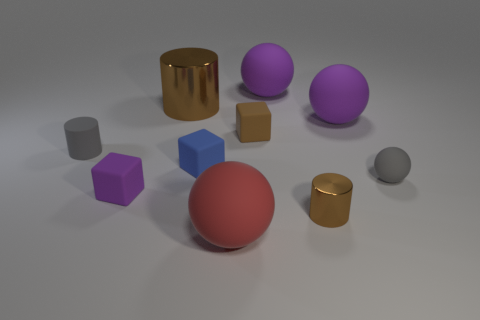There is a block that is the same color as the large metal thing; what material is it?
Keep it short and to the point. Rubber. How many other objects are the same color as the big cylinder?
Your answer should be compact. 2. Are there more small brown metal cylinders on the right side of the gray matte cylinder than large cyan cubes?
Offer a very short reply. Yes. What number of purple matte objects have the same size as the red matte thing?
Make the answer very short. 2. There is a metal object that is right of the red rubber thing; is it the same size as the ball that is in front of the small gray ball?
Your response must be concise. No. What size is the brown shiny object that is in front of the tiny gray cylinder?
Provide a succinct answer. Small. There is a gray rubber cylinder that is left of the shiny object in front of the large brown object; how big is it?
Your answer should be very brief. Small. There is a brown cylinder that is the same size as the blue thing; what material is it?
Your answer should be very brief. Metal. Are there any gray objects on the right side of the small gray cylinder?
Provide a succinct answer. Yes. Are there an equal number of small things that are behind the tiny brown shiny thing and small gray rubber objects?
Provide a succinct answer. No. 